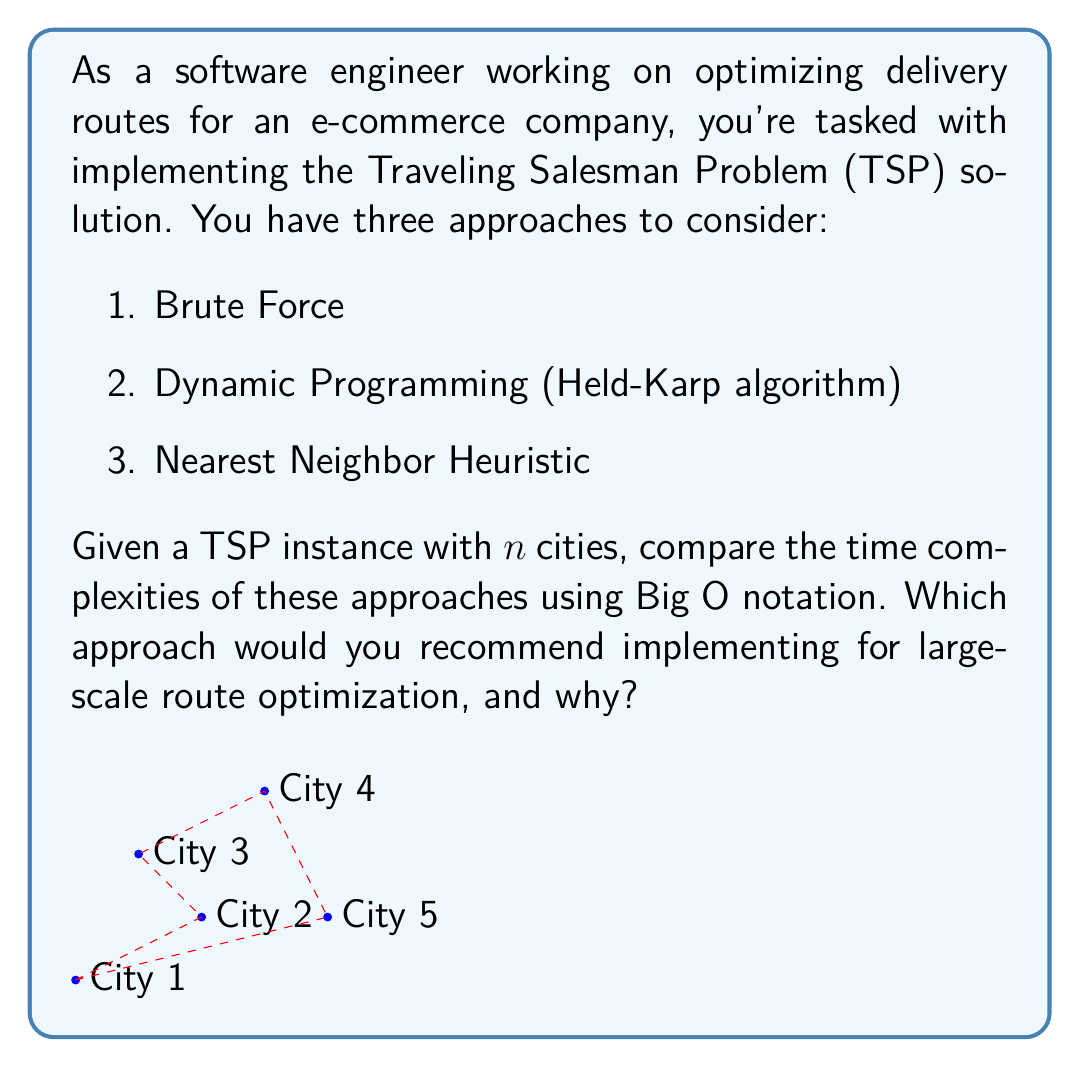What is the answer to this math problem? Let's analyze each approach:

1. Brute Force:
   - Generates all possible permutations of cities.
   - Time complexity: $O(n!)$
   - For $n$ cities, there are $n!$ possible routes to check.

2. Dynamic Programming (Held-Karp algorithm):
   - Uses memoization to avoid redundant calculations.
   - Time complexity: $O(n^2 2^n)$
   - Solves subproblems for all subsets of cities and all possible last cities.

3. Nearest Neighbor Heuristic:
   - Greedy approach, always choosing the nearest unvisited city.
   - Time complexity: $O(n^2)$
   - For each of $n$ steps, it compares distances to at most $n-1$ cities.

Comparison:
- For small $n$, Brute Force might be acceptable.
- As $n$ increases, Brute Force becomes impractical due to factorial growth.
- Dynamic Programming is significantly faster than Brute Force for larger $n$.
- Nearest Neighbor is the fastest but doesn't guarantee an optimal solution.

For large-scale route optimization:
- Nearest Neighbor is recommended for its efficiency ($O(n^2)$).
- It provides a good trade-off between speed and solution quality.
- In a corporate setting, quick approximations are often more valuable than time-consuming optimal solutions.
- The algorithm can be easily explained to non-technical stakeholders.
- It allows for real-time route adjustments, which is crucial in dynamic delivery scenarios.
Answer: Recommend Nearest Neighbor Heuristic ($O(n^2)$) for large-scale optimization due to its efficiency and practicality in corporate settings, despite not guaranteeing optimal solutions. 